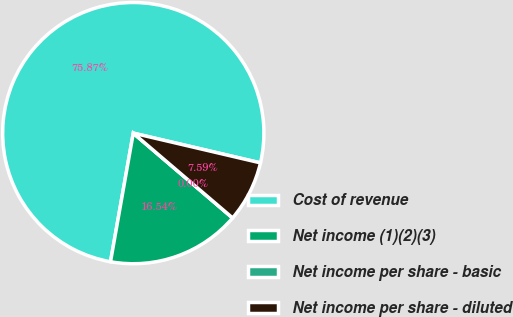Convert chart to OTSL. <chart><loc_0><loc_0><loc_500><loc_500><pie_chart><fcel>Cost of revenue<fcel>Net income (1)(2)(3)<fcel>Net income per share - basic<fcel>Net income per share - diluted<nl><fcel>75.87%<fcel>16.54%<fcel>0.0%<fcel>7.59%<nl></chart> 